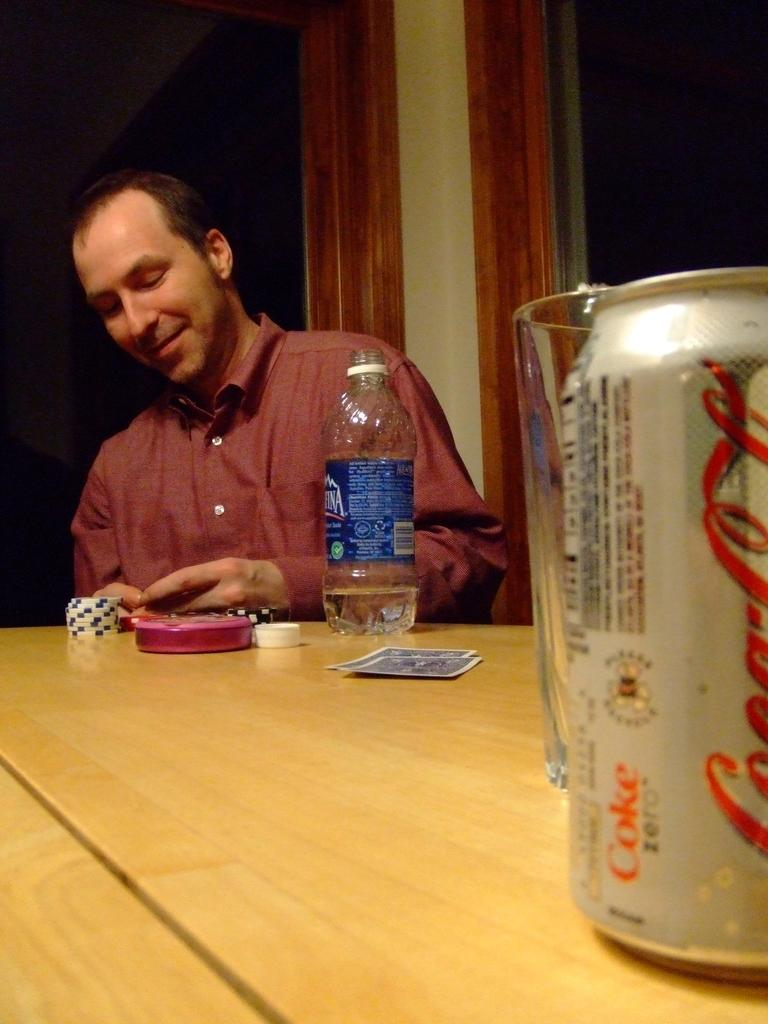What is the person in the image doing? The person is sitting in front of a table. What can be seen on the table in the image? The table has a coke, a glass, a water bottle, playing cards, and some other objects. What type of beverage is visible on the table? There is a coke on the table. What might the person be using to drink from? The person might be using the glass on the table to drink from. What type of frame is visible in the image? There is no frame present in the image. Is the person taking a bath in the image? No, the person is sitting in front of a table, not taking a bath. 